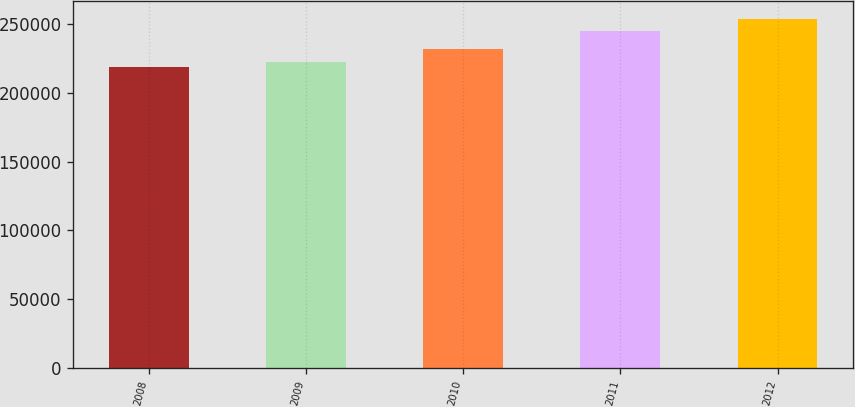Convert chart to OTSL. <chart><loc_0><loc_0><loc_500><loc_500><bar_chart><fcel>2008<fcel>2009<fcel>2010<fcel>2011<fcel>2012<nl><fcel>219000<fcel>222500<fcel>232000<fcel>245000<fcel>254000<nl></chart> 